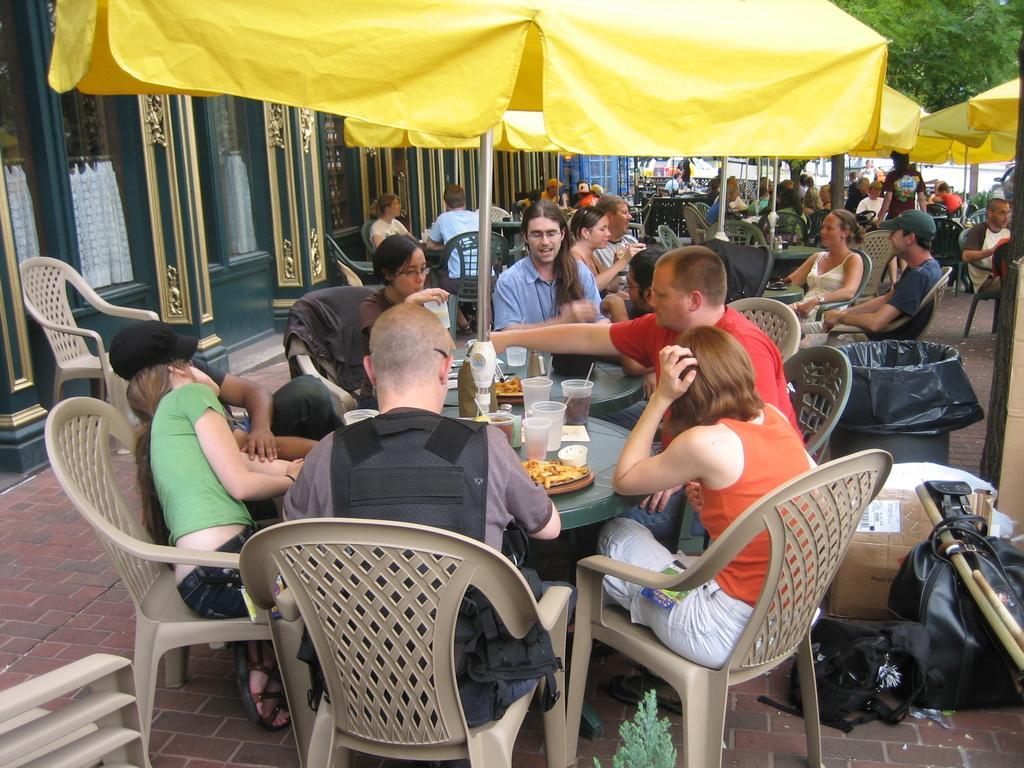Can you describe this image briefly? Here we can see a group of people sitting on chairs with a table in front of them having food 